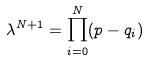Convert formula to latex. <formula><loc_0><loc_0><loc_500><loc_500>\lambda ^ { N + 1 } = \prod _ { i = 0 } ^ { N } ( p - q _ { i } )</formula> 